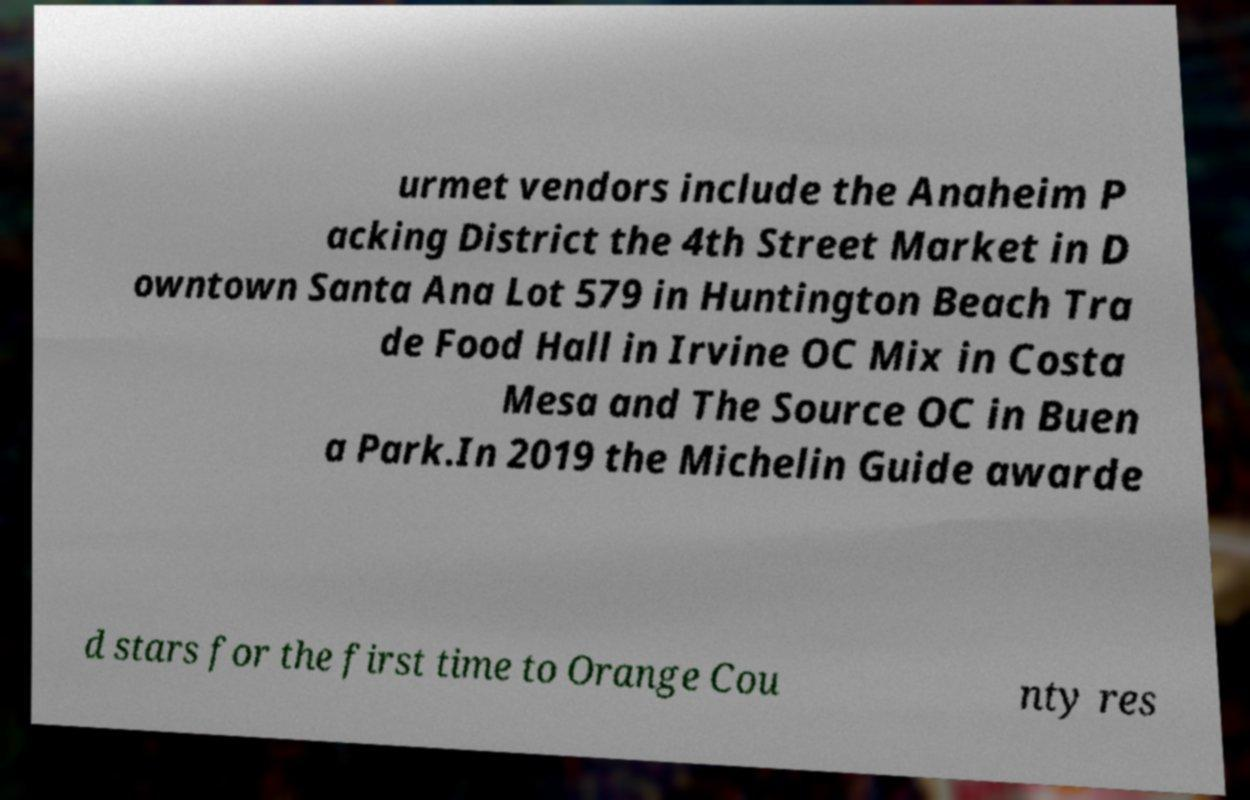Can you read and provide the text displayed in the image?This photo seems to have some interesting text. Can you extract and type it out for me? urmet vendors include the Anaheim P acking District the 4th Street Market in D owntown Santa Ana Lot 579 in Huntington Beach Tra de Food Hall in Irvine OC Mix in Costa Mesa and The Source OC in Buen a Park.In 2019 the Michelin Guide awarde d stars for the first time to Orange Cou nty res 